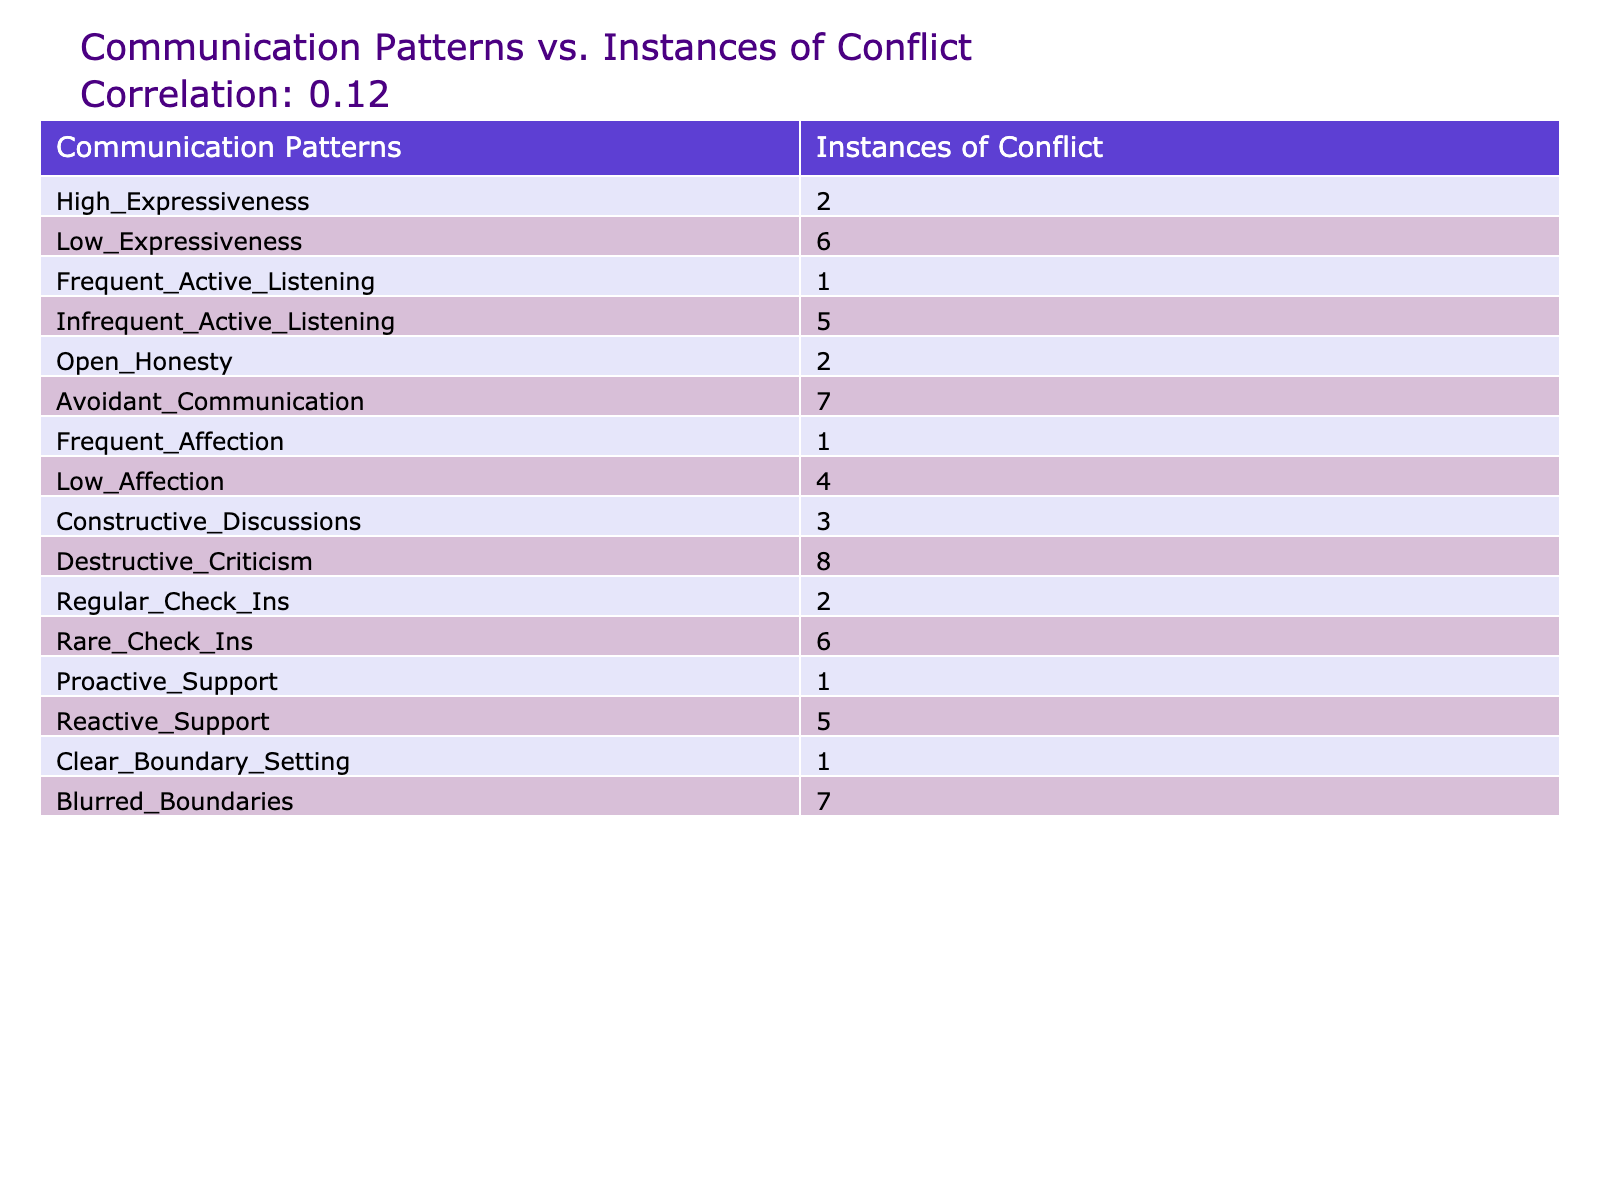What is the least number of instances of conflict observed? The least number of instances of conflict is found by scanning through the column 'Instances of Conflict.' The lowest value in that column is 1, associated with the communication patterns 'Frequent Active Listening,' 'Frequent Affection,' 'Proactive Support,' and 'Clear Boundary Setting.'
Answer: 1 Which communication pattern has the highest instances of conflict? By examining the 'Instances of Conflict' column, 'Destructive Criticism' has the highest value at 8, indicating it is linked to the most frequent conflicts in relationships.
Answer: 8 What is the average number of instances of conflict across all communication patterns? To calculate the average, sum all the values in the 'Instances of Conflict' column: 2 + 6 + 1 + 5 + 2 + 7 + 1 + 4 + 3 + 8 + 2 + 6 + 1 + 5 + 1 + 7 = 52. There are 16 data points, so the average is 52 / 16 = 3.25.
Answer: 3.25 Is there a positive correlation between high expressiveness and low instances of conflict? To determine this, compare the instances of conflict for 'High Expressiveness' (2) and 'Low Expressiveness' (6). A lower number of conflicts with high expressiveness suggests a negative correlation instead. Hence, there is not a positive correlation.
Answer: No What is the difference in instances of conflict between 'Avoidant Communication' and 'Frequent Active Listening'? The 'Instances of Conflict' for 'Avoidant Communication' is 7, while for 'Frequent Active Listening' it is 1. The difference is 7 - 1 = 6, indicating that avoidant communication leads to significantly more conflicts.
Answer: 6 Which communication pattern resulted in more instances of conflict: 'Rare Check-Ins' or 'Regular Check-Ins'? Comparing the two, 'Rare Check-Ins' has 6 instances of conflict while 'Regular Check-Ins' has 2. Clearly, 'Rare Check-Ins' leads to more instances of conflict, as it has a higher value.
Answer: Rare Check-Ins What is the sum of instances of conflict for communication patterns that involve support? The relevant patterns are 'Proactive Support' (1) and 'Reactive Support' (5). Summing these gives 1 + 5 = 6. Thus, the total for support-related patterns is 6.
Answer: 6 Do the patterns related to affection have higher or lower conflict instances compared to active listening? For affection, 'Frequent Affection' has 1 and 'Low Affection' has 4, summing to 5. For active listening, 'Frequent Active Listening' has 1 and 'Infrequent Active Listening' has 5, totaling 6. Since 6 > 5, affection patterns have lower conflict.
Answer: Lower What is the relationship between the patterns involving honesty and instances of conflict? The relevant pattern is 'Open Honesty,' which has 2 instances of conflict. Other patterns related to communication (e.g., 'Destructive Criticism') have 8 instances. The effect of honesty looks to mitigate conflict comparatively against more negative patterns.
Answer: Mitigating 